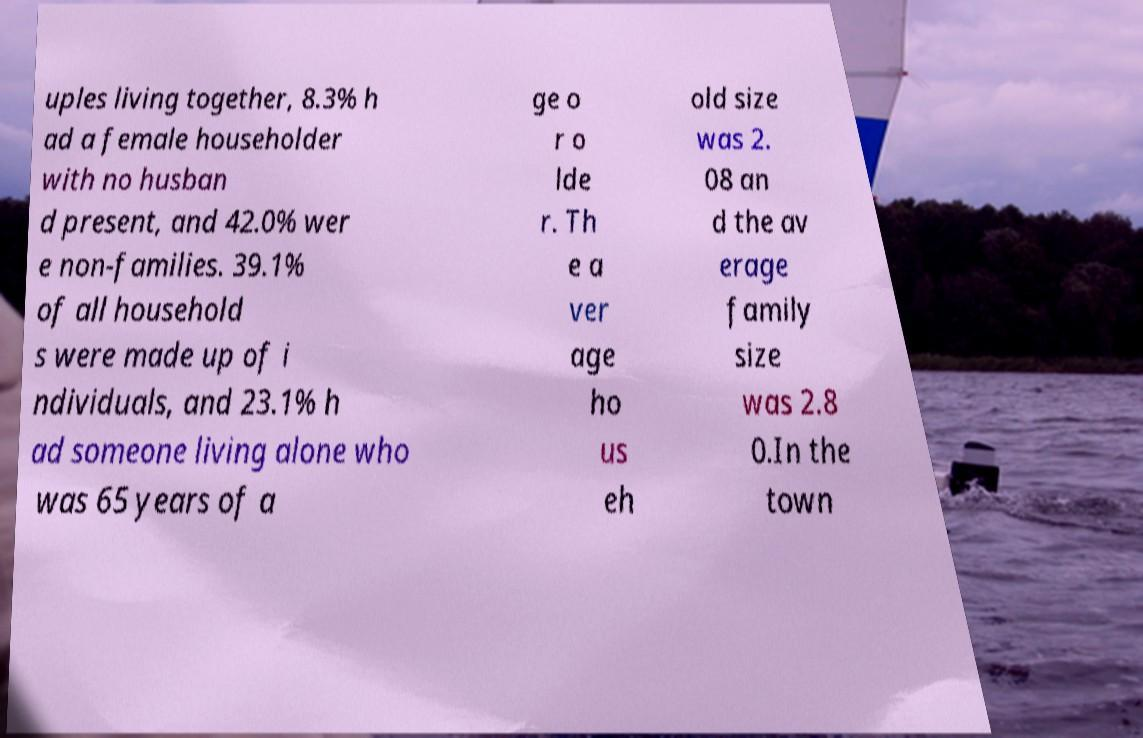Could you extract and type out the text from this image? uples living together, 8.3% h ad a female householder with no husban d present, and 42.0% wer e non-families. 39.1% of all household s were made up of i ndividuals, and 23.1% h ad someone living alone who was 65 years of a ge o r o lde r. Th e a ver age ho us eh old size was 2. 08 an d the av erage family size was 2.8 0.In the town 